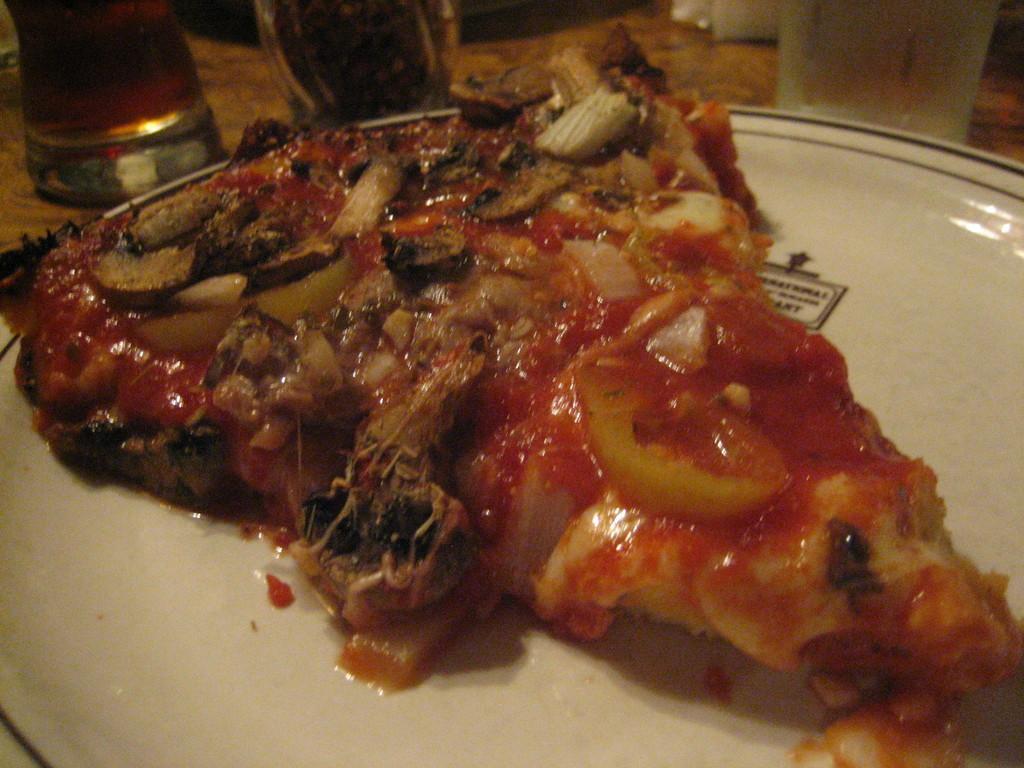Describe this image in one or two sentences. In this image I can see the plate with food. The plate is in white color and the food is colorful. To the side I can see the glasses. These are on the brown color surface. 